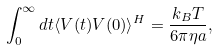Convert formula to latex. <formula><loc_0><loc_0><loc_500><loc_500>\int _ { 0 } ^ { \infty } d t \langle V ( t ) V ( 0 ) \rangle ^ { H } = \frac { k _ { B } T } { 6 \pi \eta a } ,</formula> 